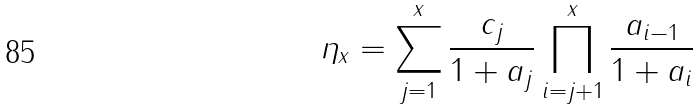<formula> <loc_0><loc_0><loc_500><loc_500>\eta _ { x } = \sum ^ { x } _ { j = 1 } \frac { c _ { j } } { 1 + a _ { j } } \prod ^ { x } _ { i = j + 1 } \frac { a _ { i - 1 } } { 1 + a _ { i } }</formula> 